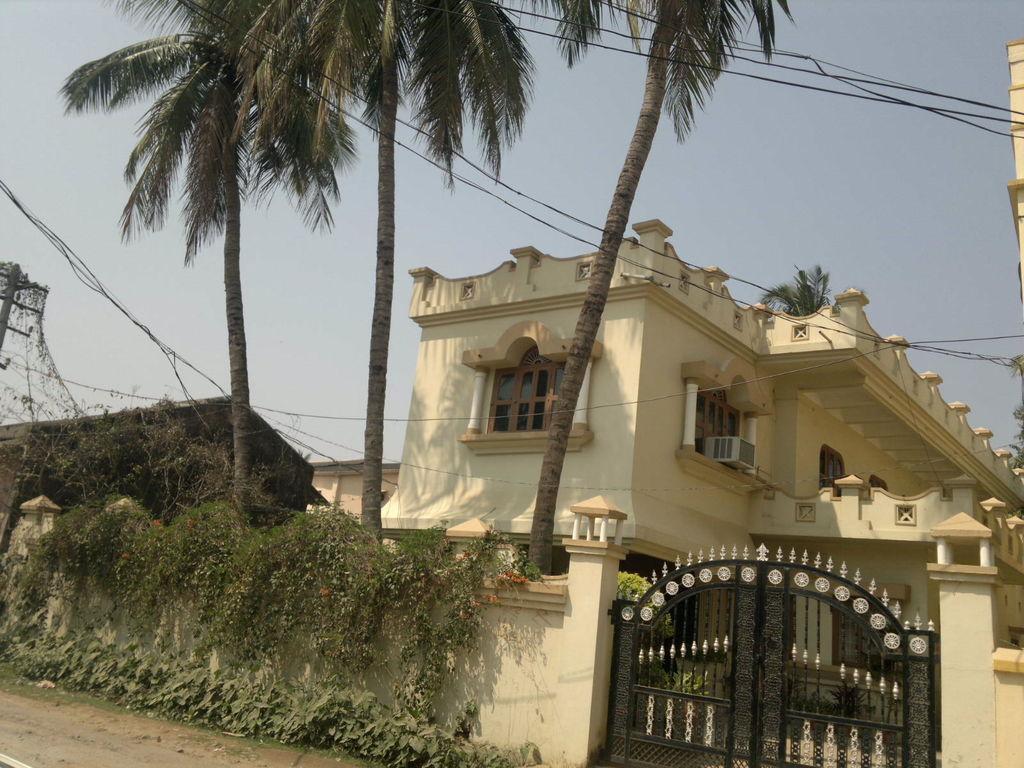Describe this image in one or two sentences. This is the picture of a building to which there are some windows and around there are some trees, plants and some wires. 